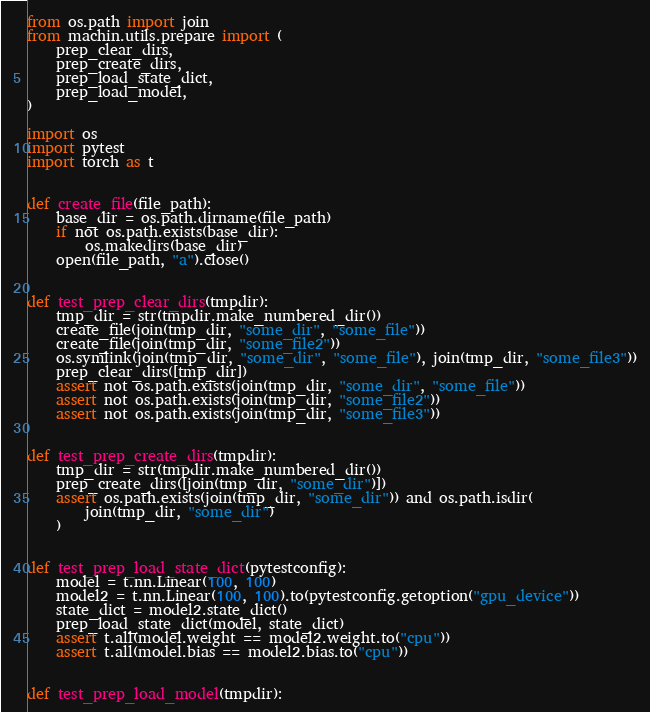<code> <loc_0><loc_0><loc_500><loc_500><_Python_>from os.path import join
from machin.utils.prepare import (
    prep_clear_dirs,
    prep_create_dirs,
    prep_load_state_dict,
    prep_load_model,
)

import os
import pytest
import torch as t


def create_file(file_path):
    base_dir = os.path.dirname(file_path)
    if not os.path.exists(base_dir):
        os.makedirs(base_dir)
    open(file_path, "a").close()


def test_prep_clear_dirs(tmpdir):
    tmp_dir = str(tmpdir.make_numbered_dir())
    create_file(join(tmp_dir, "some_dir", "some_file"))
    create_file(join(tmp_dir, "some_file2"))
    os.symlink(join(tmp_dir, "some_dir", "some_file"), join(tmp_dir, "some_file3"))
    prep_clear_dirs([tmp_dir])
    assert not os.path.exists(join(tmp_dir, "some_dir", "some_file"))
    assert not os.path.exists(join(tmp_dir, "some_file2"))
    assert not os.path.exists(join(tmp_dir, "some_file3"))


def test_prep_create_dirs(tmpdir):
    tmp_dir = str(tmpdir.make_numbered_dir())
    prep_create_dirs([join(tmp_dir, "some_dir")])
    assert os.path.exists(join(tmp_dir, "some_dir")) and os.path.isdir(
        join(tmp_dir, "some_dir")
    )


def test_prep_load_state_dict(pytestconfig):
    model = t.nn.Linear(100, 100)
    model2 = t.nn.Linear(100, 100).to(pytestconfig.getoption("gpu_device"))
    state_dict = model2.state_dict()
    prep_load_state_dict(model, state_dict)
    assert t.all(model.weight == model2.weight.to("cpu"))
    assert t.all(model.bias == model2.bias.to("cpu"))


def test_prep_load_model(tmpdir):</code> 